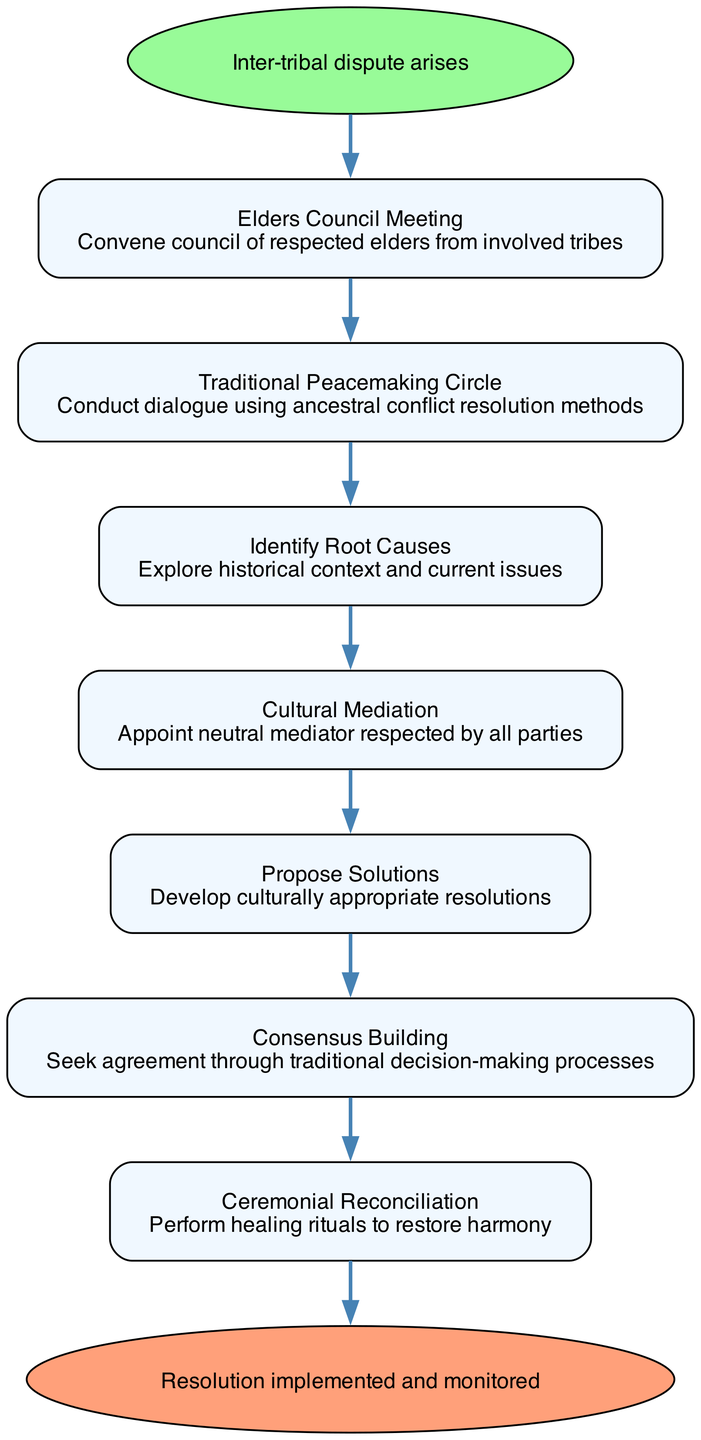What is the first step in the conflict resolution procedure? The first step is identified as "Elders Council Meeting" in the diagram, indicating that this is where the process begins.
Answer: Elders Council Meeting How many steps are there in total? By counting the steps listed in the diagram, we find there are seven distinct steps before reaching the conclusion.
Answer: 7 What action follows "Identify Root Causes"? The diagram indicates that after "Identify Root Causes", the next action to be taken is "Cultural Mediation". This shows the flow of actions in handling the dispute.
Answer: Cultural Mediation What type of mediation is appointed? The diagram specifies that "Cultural Mediation" involves appointing a neutral mediator who is respected by all parties, emphasizing the importance of cultural sensitivity.
Answer: Neutral mediator What is the final step in the resolution procedure? The last step in the process is labeled "Ceremonial Reconciliation", which signifies the culmination of the steps taken to address the dispute.
Answer: Ceremonial Reconciliation Which step aims at seeking agreement? The diagram shows that "Consensus Building" is the step dedicated to seeking agreement, indicating its importance in reaching an amicable resolution.
Answer: Consensus Building How does the resolution process begin? The resolution process begins with "Inter-tribal dispute arises", serving as the trigger for all subsequent actions outlined in the diagram.
Answer: Inter-tribal dispute arises 